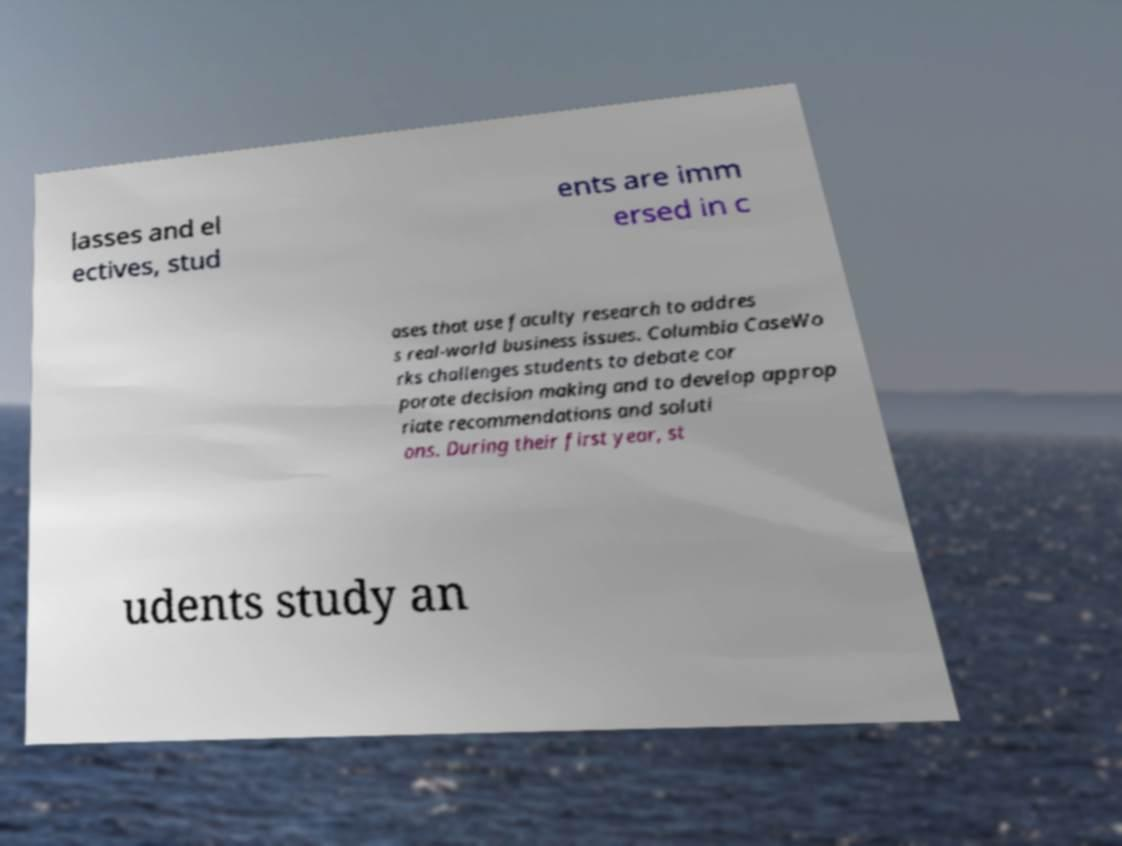Could you extract and type out the text from this image? lasses and el ectives, stud ents are imm ersed in c ases that use faculty research to addres s real-world business issues. Columbia CaseWo rks challenges students to debate cor porate decision making and to develop approp riate recommendations and soluti ons. During their first year, st udents study an 